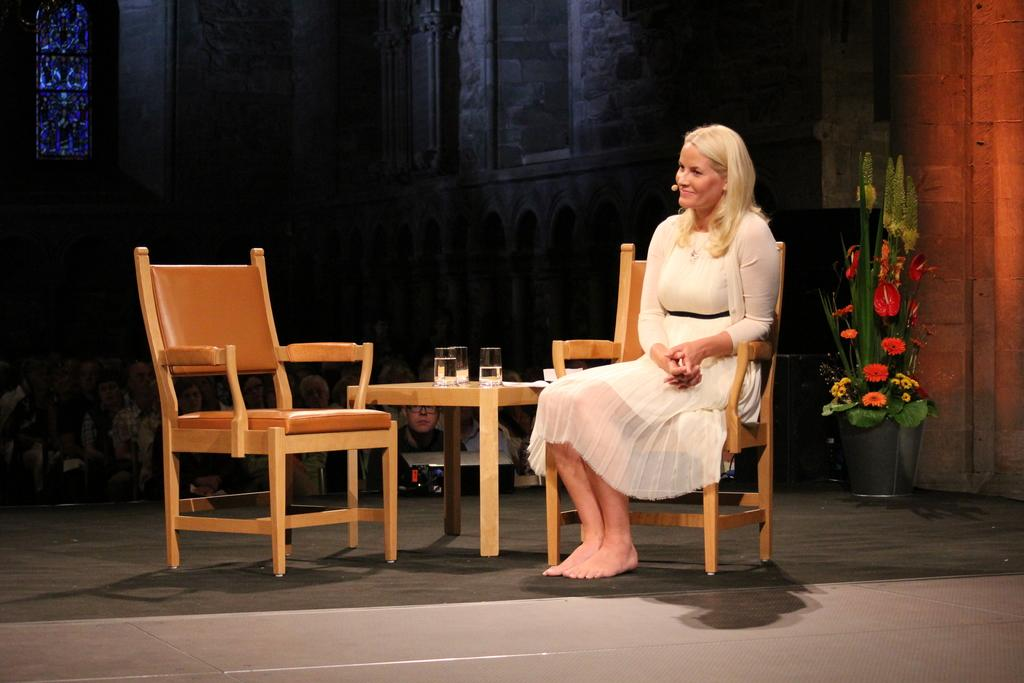What is the woman in the image doing? The woman is sitting in a chair. What is located near the woman? There is a table in the image. What is on the table? There is a glass on the table. How many chairs are visible in the image? There are two chairs visible in the image. What can be seen in the background of the image? There are people standing in the background, a plant, and a window. What type of credit can be seen being exchanged between the woman and the people in the background? There is no credit exchange depicted in the image; it only shows a woman sitting in a chair, a table with a glass, and people standing in the background. 